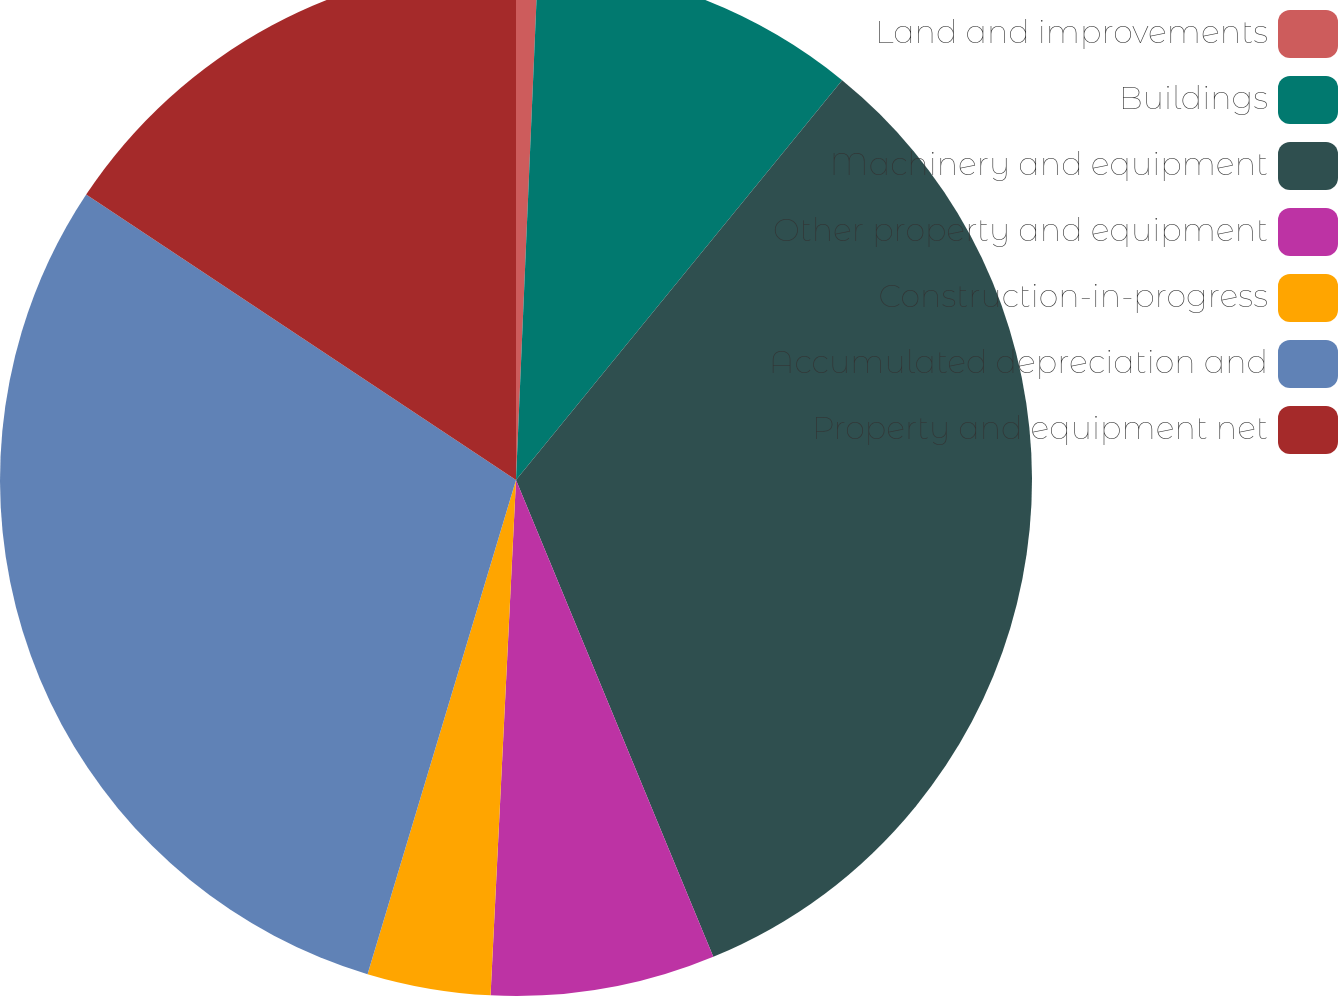Convert chart. <chart><loc_0><loc_0><loc_500><loc_500><pie_chart><fcel>Land and improvements<fcel>Buildings<fcel>Machinery and equipment<fcel>Other property and equipment<fcel>Construction-in-progress<fcel>Accumulated depreciation and<fcel>Property and equipment net<nl><fcel>0.68%<fcel>10.21%<fcel>32.87%<fcel>7.03%<fcel>3.86%<fcel>29.69%<fcel>15.67%<nl></chart> 